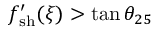<formula> <loc_0><loc_0><loc_500><loc_500>f _ { s h } ^ { \prime } ( \xi ) > \tan \theta _ { 2 5 }</formula> 